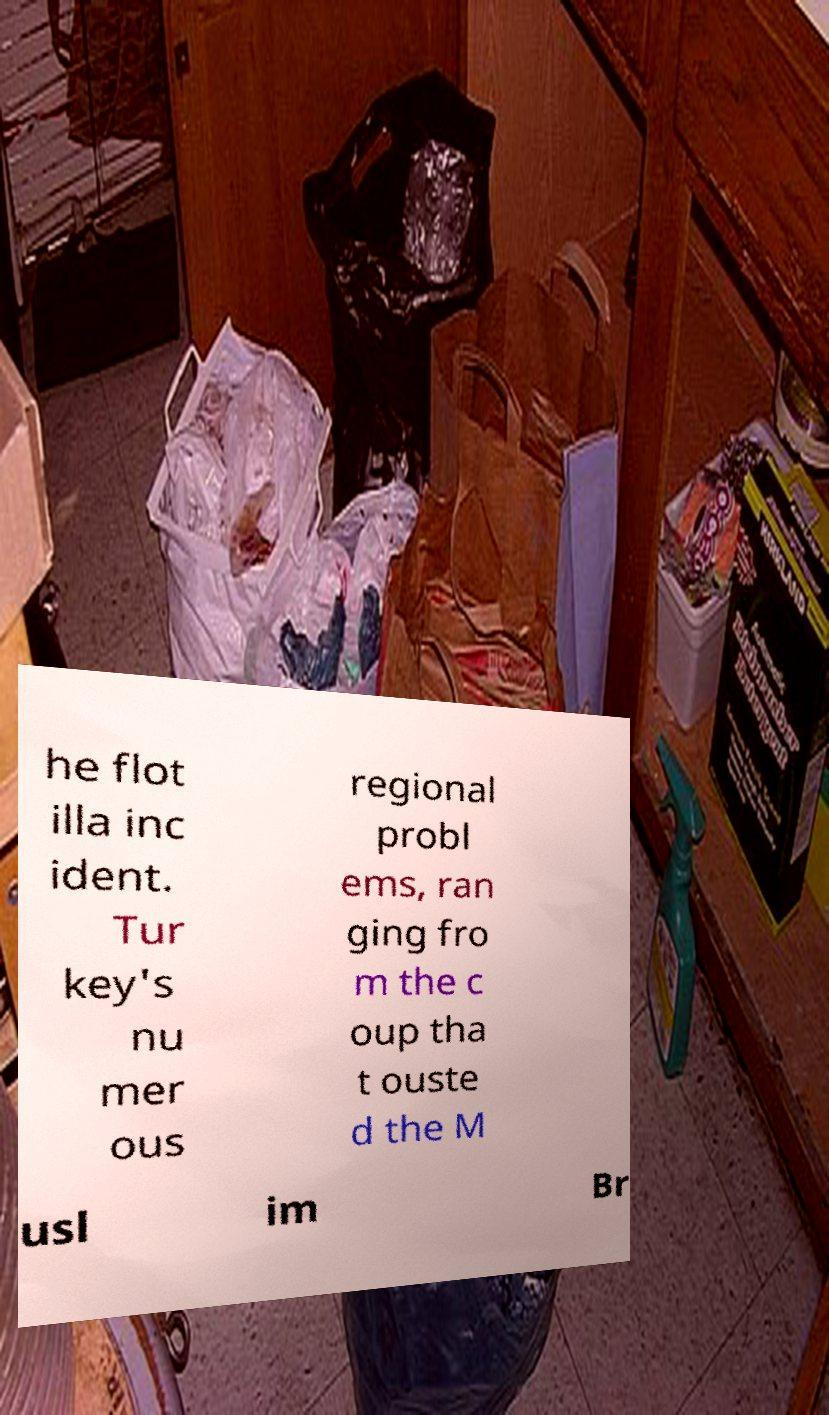Can you accurately transcribe the text from the provided image for me? he flot illa inc ident. Tur key's nu mer ous regional probl ems, ran ging fro m the c oup tha t ouste d the M usl im Br 